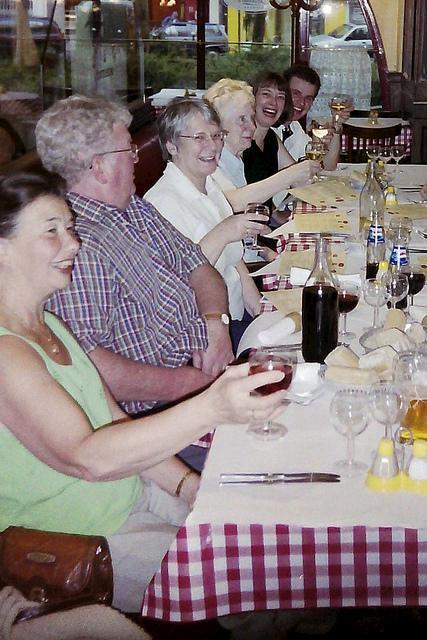How many people can you see?
Give a very brief answer. 6. How many birds are shown?
Give a very brief answer. 0. 